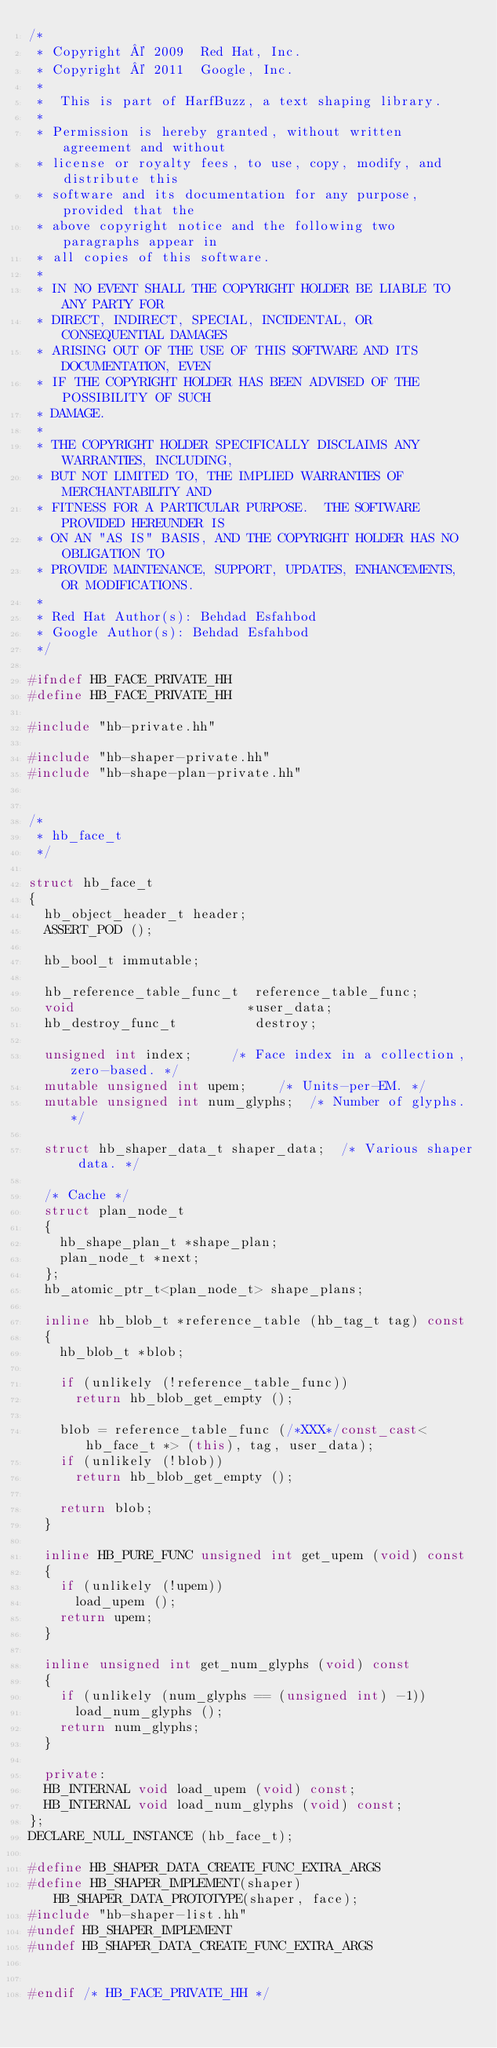<code> <loc_0><loc_0><loc_500><loc_500><_C++_>/*
 * Copyright © 2009  Red Hat, Inc.
 * Copyright © 2011  Google, Inc.
 *
 *  This is part of HarfBuzz, a text shaping library.
 *
 * Permission is hereby granted, without written agreement and without
 * license or royalty fees, to use, copy, modify, and distribute this
 * software and its documentation for any purpose, provided that the
 * above copyright notice and the following two paragraphs appear in
 * all copies of this software.
 *
 * IN NO EVENT SHALL THE COPYRIGHT HOLDER BE LIABLE TO ANY PARTY FOR
 * DIRECT, INDIRECT, SPECIAL, INCIDENTAL, OR CONSEQUENTIAL DAMAGES
 * ARISING OUT OF THE USE OF THIS SOFTWARE AND ITS DOCUMENTATION, EVEN
 * IF THE COPYRIGHT HOLDER HAS BEEN ADVISED OF THE POSSIBILITY OF SUCH
 * DAMAGE.
 *
 * THE COPYRIGHT HOLDER SPECIFICALLY DISCLAIMS ANY WARRANTIES, INCLUDING,
 * BUT NOT LIMITED TO, THE IMPLIED WARRANTIES OF MERCHANTABILITY AND
 * FITNESS FOR A PARTICULAR PURPOSE.  THE SOFTWARE PROVIDED HEREUNDER IS
 * ON AN "AS IS" BASIS, AND THE COPYRIGHT HOLDER HAS NO OBLIGATION TO
 * PROVIDE MAINTENANCE, SUPPORT, UPDATES, ENHANCEMENTS, OR MODIFICATIONS.
 *
 * Red Hat Author(s): Behdad Esfahbod
 * Google Author(s): Behdad Esfahbod
 */

#ifndef HB_FACE_PRIVATE_HH
#define HB_FACE_PRIVATE_HH

#include "hb-private.hh"

#include "hb-shaper-private.hh"
#include "hb-shape-plan-private.hh"


/*
 * hb_face_t
 */

struct hb_face_t
{
  hb_object_header_t header;
  ASSERT_POD ();

  hb_bool_t immutable;

  hb_reference_table_func_t  reference_table_func;
  void                      *user_data;
  hb_destroy_func_t          destroy;

  unsigned int index;			/* Face index in a collection, zero-based. */
  mutable unsigned int upem;		/* Units-per-EM. */
  mutable unsigned int num_glyphs;	/* Number of glyphs. */

  struct hb_shaper_data_t shaper_data;	/* Various shaper data. */

  /* Cache */
  struct plan_node_t
  {
    hb_shape_plan_t *shape_plan;
    plan_node_t *next;
  };
  hb_atomic_ptr_t<plan_node_t> shape_plans;

  inline hb_blob_t *reference_table (hb_tag_t tag) const
  {
    hb_blob_t *blob;

    if (unlikely (!reference_table_func))
      return hb_blob_get_empty ();

    blob = reference_table_func (/*XXX*/const_cast<hb_face_t *> (this), tag, user_data);
    if (unlikely (!blob))
      return hb_blob_get_empty ();

    return blob;
  }

  inline HB_PURE_FUNC unsigned int get_upem (void) const
  {
    if (unlikely (!upem))
      load_upem ();
    return upem;
  }

  inline unsigned int get_num_glyphs (void) const
  {
    if (unlikely (num_glyphs == (unsigned int) -1))
      load_num_glyphs ();
    return num_glyphs;
  }

  private:
  HB_INTERNAL void load_upem (void) const;
  HB_INTERNAL void load_num_glyphs (void) const;
};
DECLARE_NULL_INSTANCE (hb_face_t);

#define HB_SHAPER_DATA_CREATE_FUNC_EXTRA_ARGS
#define HB_SHAPER_IMPLEMENT(shaper) HB_SHAPER_DATA_PROTOTYPE(shaper, face);
#include "hb-shaper-list.hh"
#undef HB_SHAPER_IMPLEMENT
#undef HB_SHAPER_DATA_CREATE_FUNC_EXTRA_ARGS


#endif /* HB_FACE_PRIVATE_HH */
</code> 